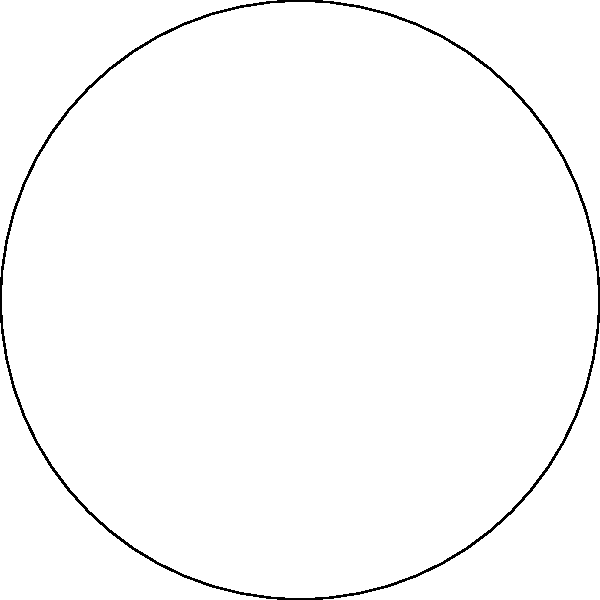A pie chart represents the distribution of retro racing game genres in a collector's library. The "Racing Sim" genre occupies a 108° sector of the chart and represents 28% of the collection. If the radius of the pie chart is 10 cm, what is the area of the sector representing the "Racing Sim" genre? To find the area of the sector, we'll follow these steps:

1) First, recall the formula for the area of a sector:
   $A = \frac{\theta}{360°} \pi r^2$
   where $\theta$ is the central angle in degrees, and $r$ is the radius.

2) We're given:
   - The central angle $\theta = 108°$
   - The radius $r = 10$ cm

3) Let's substitute these values into the formula:
   $A = \frac{108°}{360°} \pi (10 \text{ cm})^2$

4) Simplify:
   $A = \frac{3}{10} \pi (100 \text{ cm}^2)$
   $A = 30\pi \text{ cm}^2$

5) If we want to calculate the exact value:
   $A \approx 94.25 \text{ cm}^2$

Therefore, the area of the sector representing the "Racing Sim" genre is $30\pi \text{ cm}^2$ or approximately 94.25 cm².
Answer: $30\pi \text{ cm}^2$ 